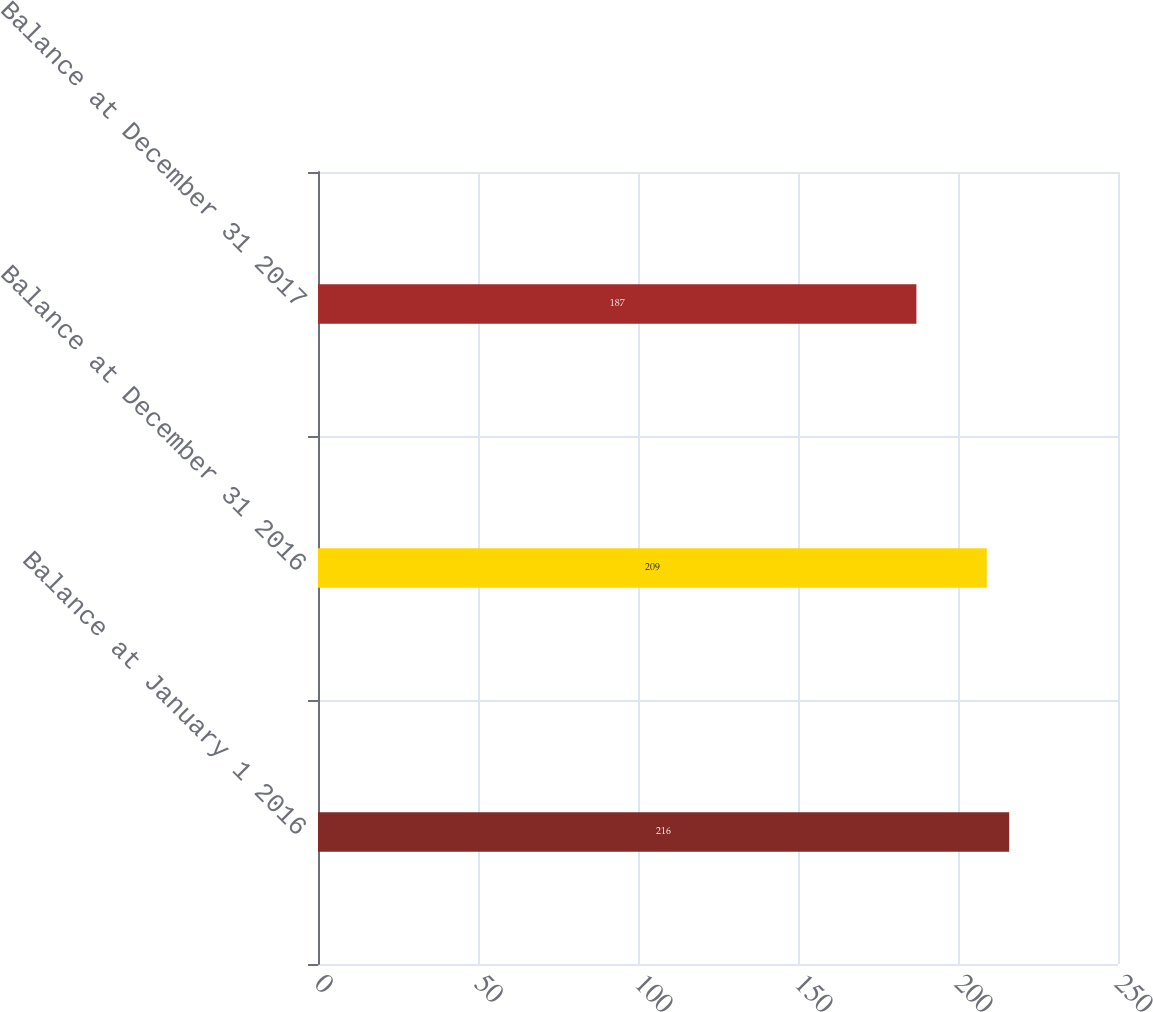Convert chart to OTSL. <chart><loc_0><loc_0><loc_500><loc_500><bar_chart><fcel>Balance at January 1 2016<fcel>Balance at December 31 2016<fcel>Balance at December 31 2017<nl><fcel>216<fcel>209<fcel>187<nl></chart> 